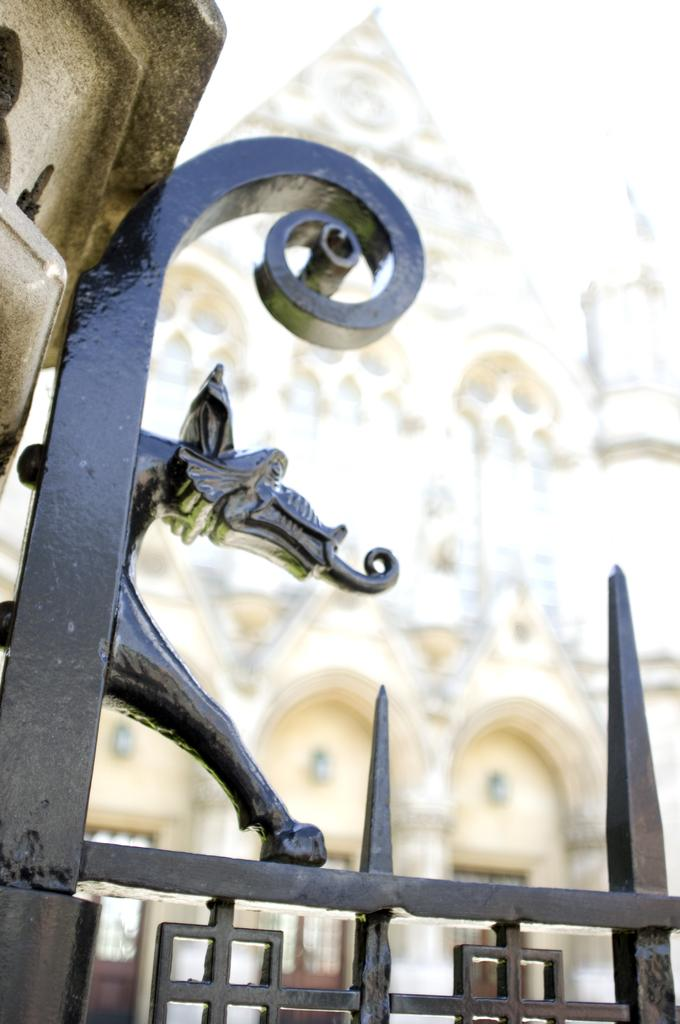What type of structure is present in the image? There is an iron grille in the image. What can be seen on the left side of the image? There is a wall on the left side top of the image. What is visible in the background of the image? There is a building in the background of the image. What scent can be detected in the image? There is no information about any scent in the image. The image only provides visual information about the iron grille, wall, and building. 